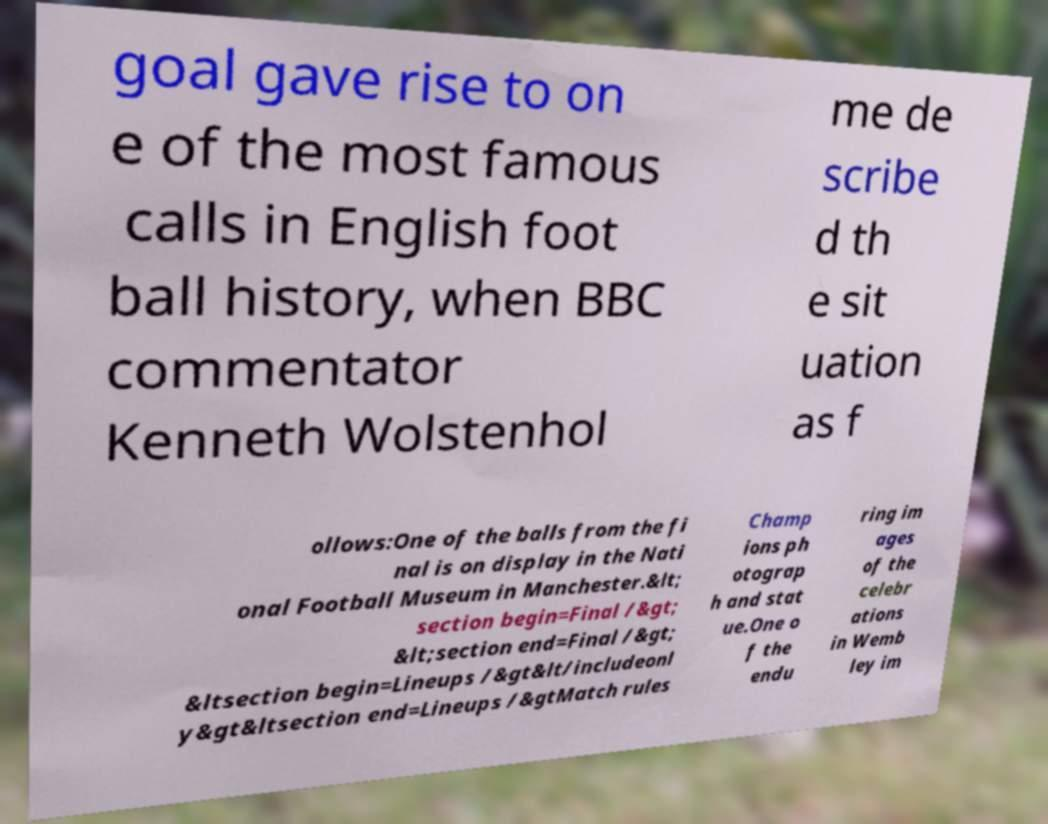There's text embedded in this image that I need extracted. Can you transcribe it verbatim? goal gave rise to on e of the most famous calls in English foot ball history, when BBC commentator Kenneth Wolstenhol me de scribe d th e sit uation as f ollows:One of the balls from the fi nal is on display in the Nati onal Football Museum in Manchester.&lt; section begin=Final /&gt; &lt;section end=Final /&gt; &ltsection begin=Lineups /&gt&lt/includeonl y&gt&ltsection end=Lineups /&gtMatch rules Champ ions ph otograp h and stat ue.One o f the endu ring im ages of the celebr ations in Wemb ley im 